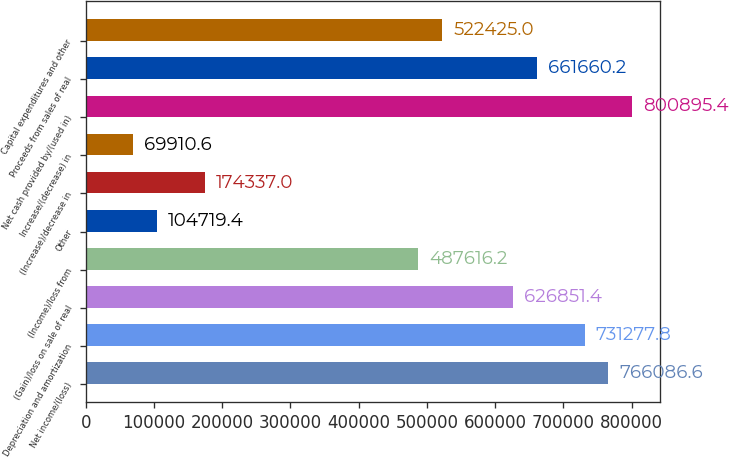Convert chart to OTSL. <chart><loc_0><loc_0><loc_500><loc_500><bar_chart><fcel>Net income/(loss)<fcel>Depreciation and amortization<fcel>(Gain)/loss on sale of real<fcel>(Income)/loss from<fcel>Other<fcel>(Increase)/decrease in<fcel>Increase/(decrease) in<fcel>Net cash provided by/(used in)<fcel>Proceeds from sales of real<fcel>Capital expenditures and other<nl><fcel>766087<fcel>731278<fcel>626851<fcel>487616<fcel>104719<fcel>174337<fcel>69910.6<fcel>800895<fcel>661660<fcel>522425<nl></chart> 